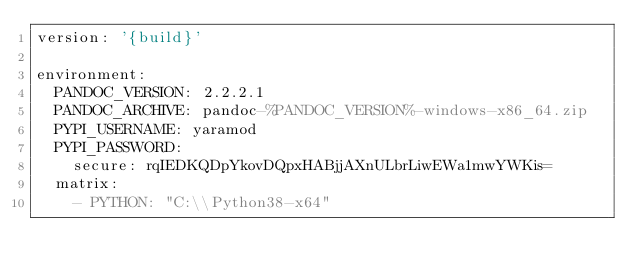<code> <loc_0><loc_0><loc_500><loc_500><_YAML_>version: '{build}'

environment:
  PANDOC_VERSION: 2.2.2.1
  PANDOC_ARCHIVE: pandoc-%PANDOC_VERSION%-windows-x86_64.zip
  PYPI_USERNAME: yaramod
  PYPI_PASSWORD:
    secure: rqIEDKQDpYkovDQpxHABjjAXnULbrLiwEWa1mwYWKis=
  matrix:
    - PYTHON: "C:\\Python38-x64"</code> 